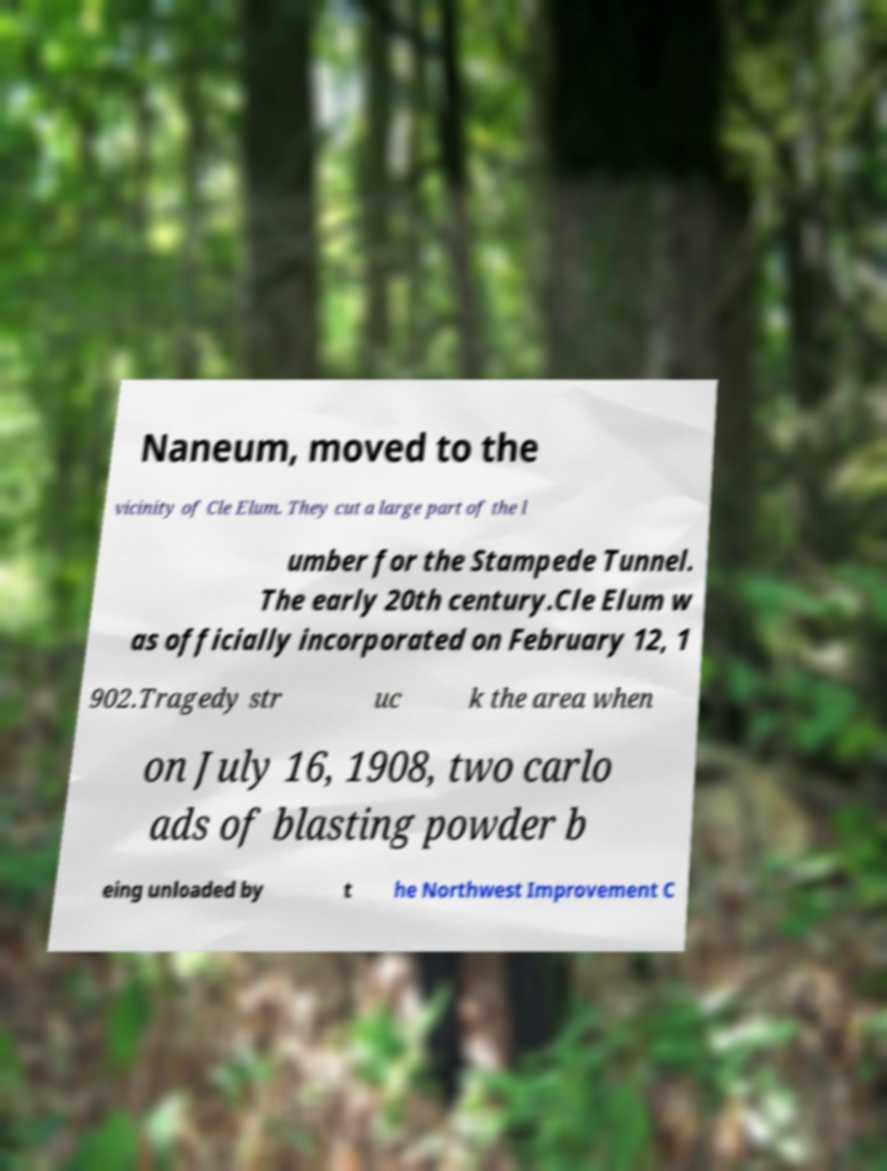Could you extract and type out the text from this image? Naneum, moved to the vicinity of Cle Elum. They cut a large part of the l umber for the Stampede Tunnel. The early 20th century.Cle Elum w as officially incorporated on February 12, 1 902.Tragedy str uc k the area when on July 16, 1908, two carlo ads of blasting powder b eing unloaded by t he Northwest Improvement C 